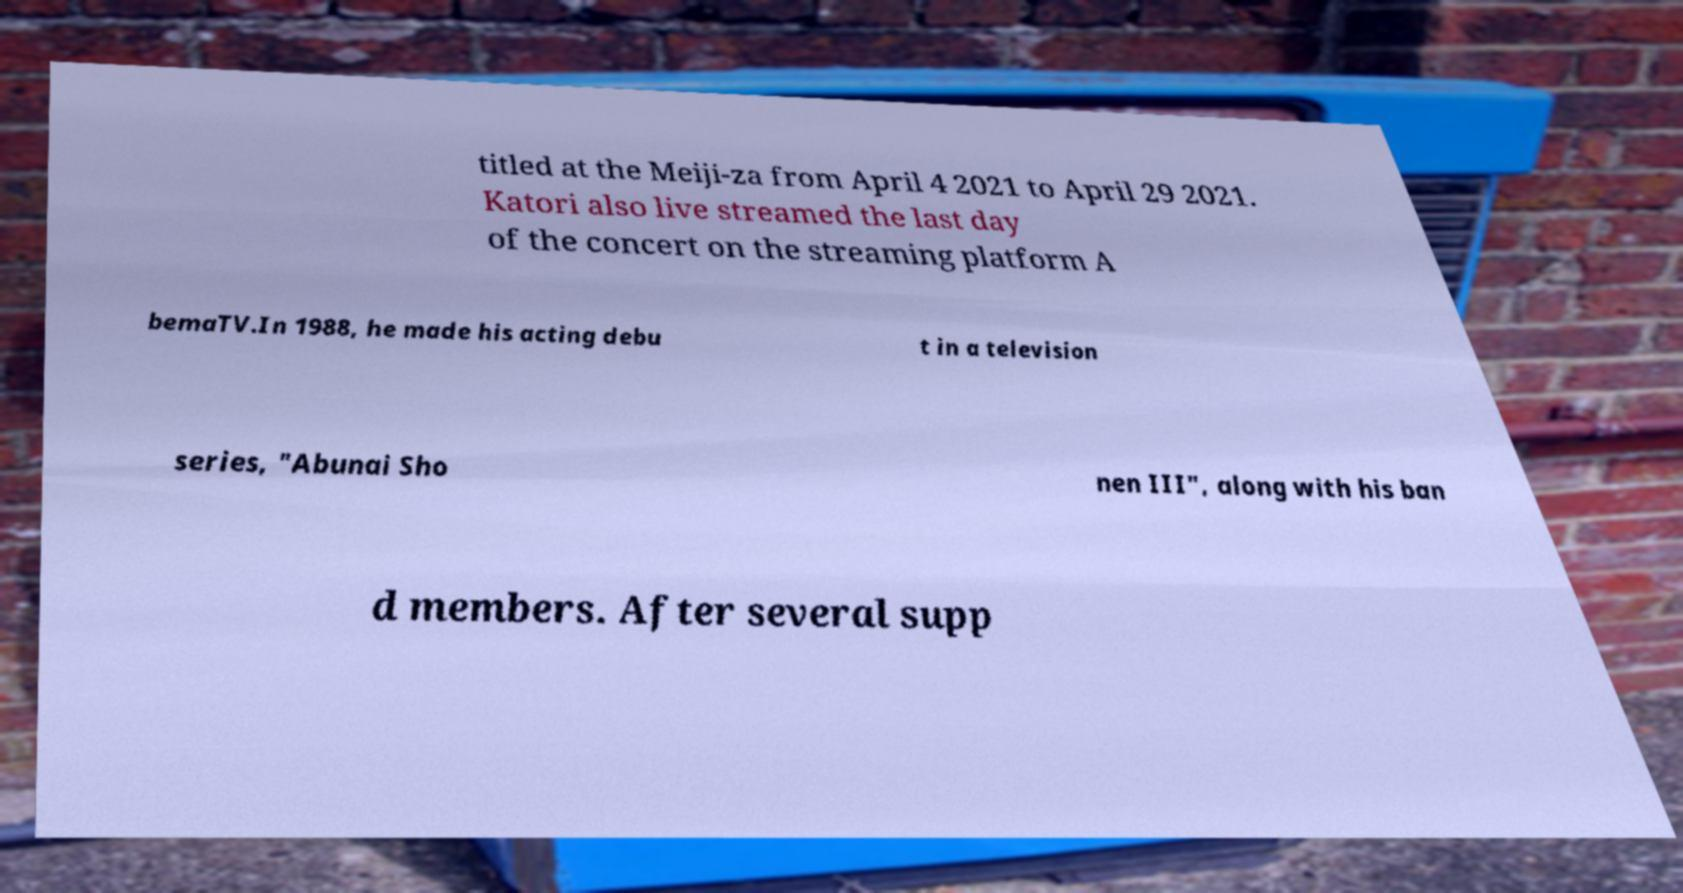Can you read and provide the text displayed in the image?This photo seems to have some interesting text. Can you extract and type it out for me? titled at the Meiji-za from April 4 2021 to April 29 2021. Katori also live streamed the last day of the concert on the streaming platform A bemaTV.In 1988, he made his acting debu t in a television series, "Abunai Sho nen III", along with his ban d members. After several supp 